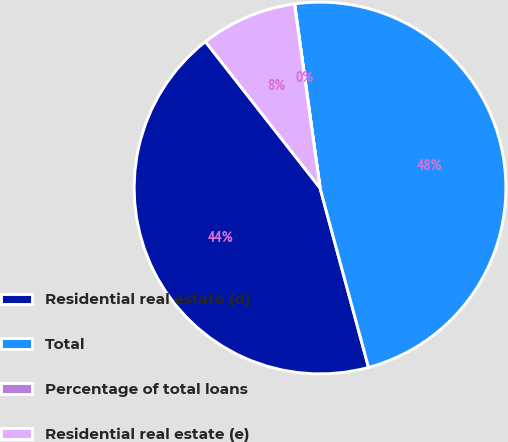Convert chart to OTSL. <chart><loc_0><loc_0><loc_500><loc_500><pie_chart><fcel>Residential real estate (d)<fcel>Total<fcel>Percentage of total loans<fcel>Residential real estate (e)<nl><fcel>43.63%<fcel>47.99%<fcel>0.02%<fcel>8.37%<nl></chart> 